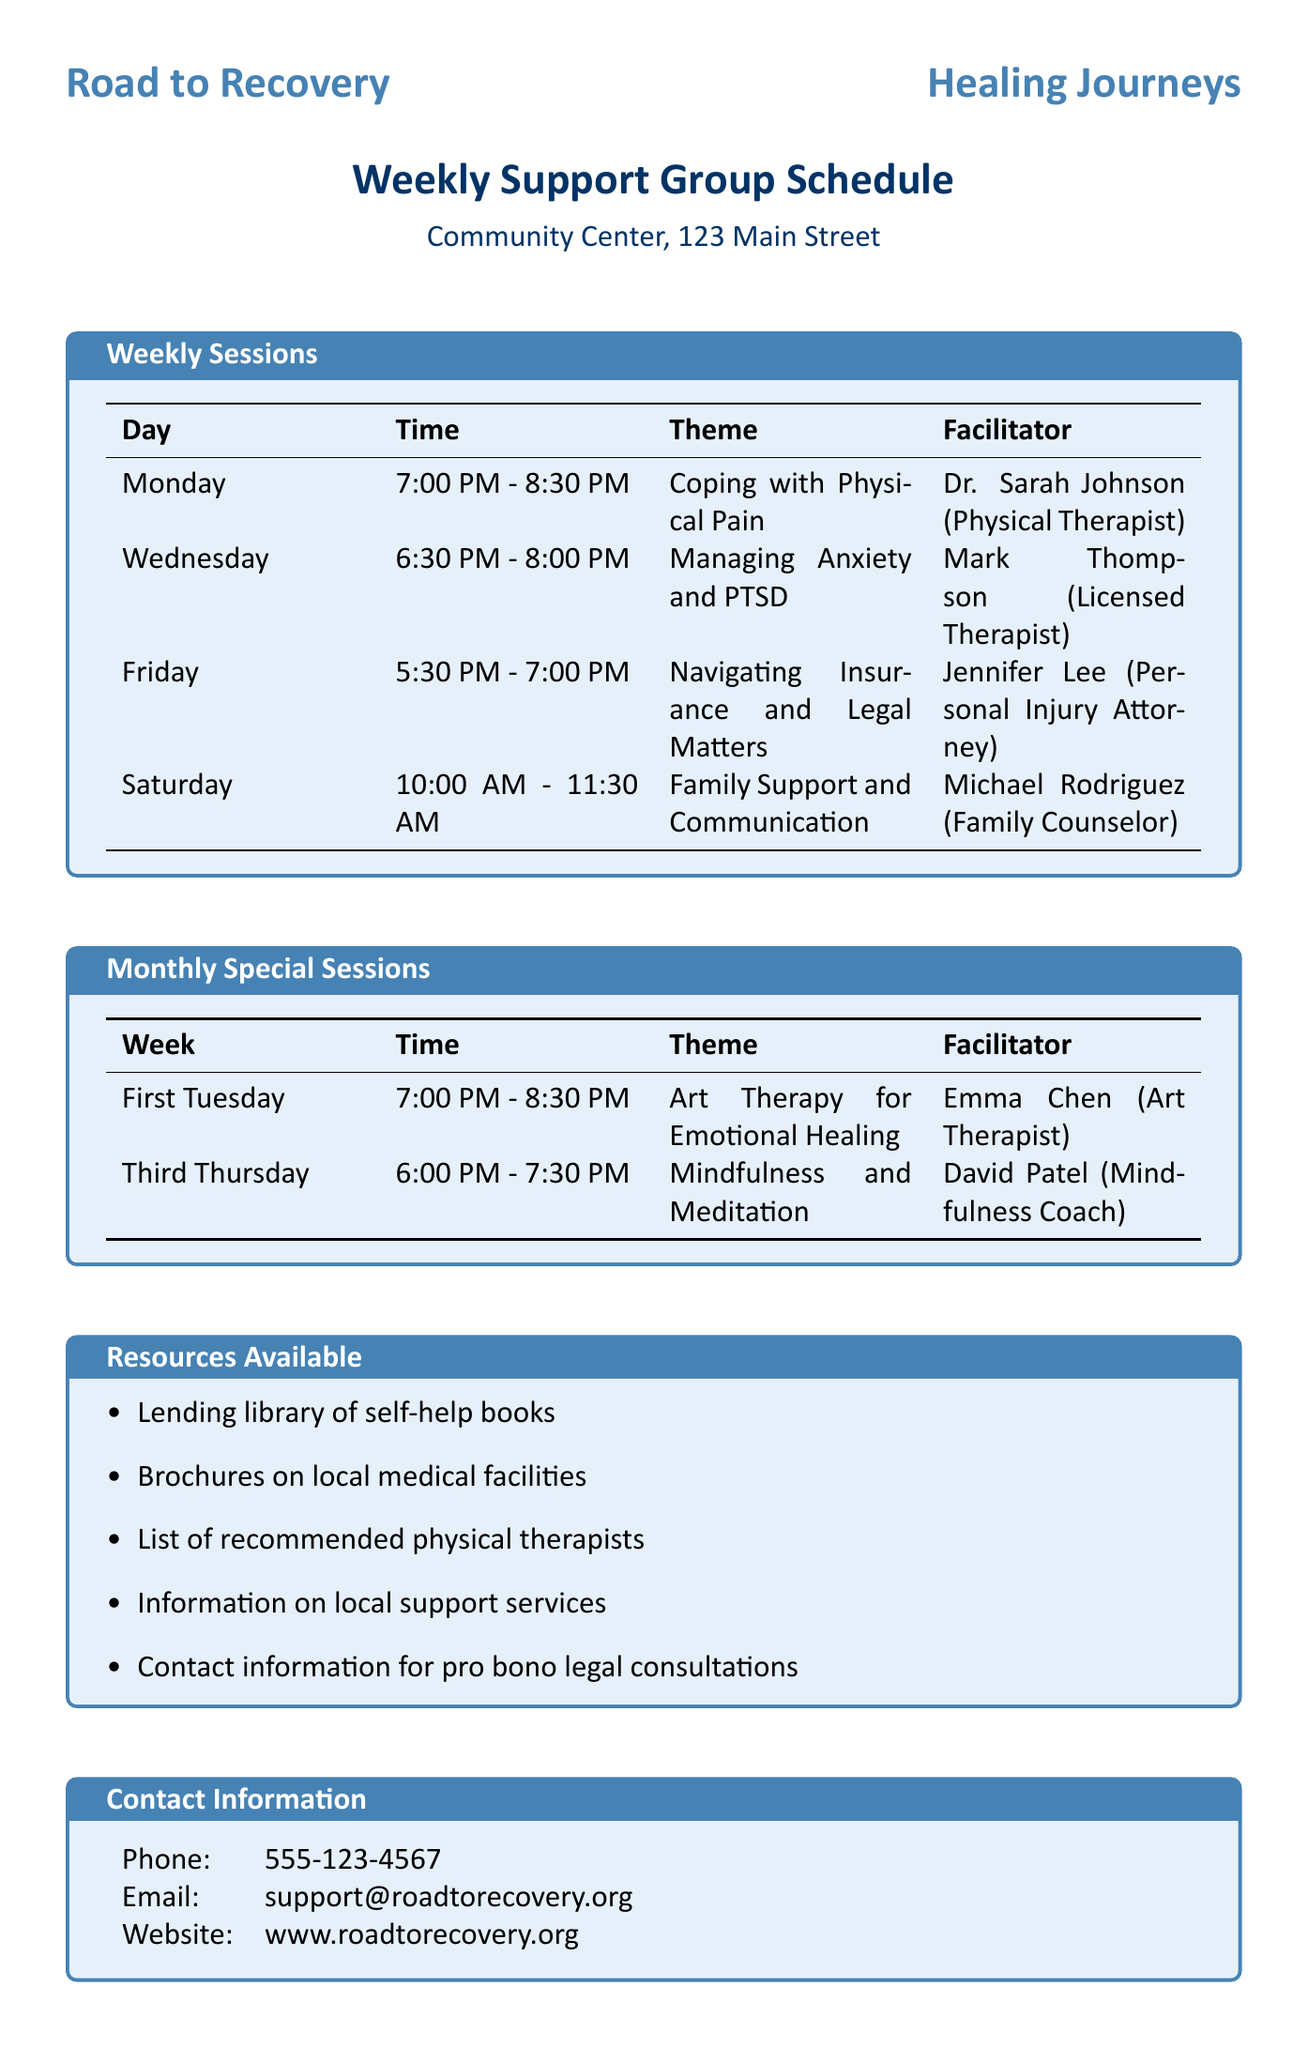What is the name of the organization? The name of the organization is listed at the top of the document, which is "Road to Recovery."
Answer: Road to Recovery What is the theme of the Wednesday session? The theme for the Wednesday session can be found in the schedule, which states "Managing Anxiety and PTSD."
Answer: Managing Anxiety and PTSD Who is the facilitator for the "Art Therapy for Emotional Healing" session? The facilitator for this monthly special session is provided in the document, which states "Emma Chen."
Answer: Emma Chen On which day is the session titled "Coping with Physical Pain" held? Referring to the weekly schedule, this theme is scheduled for "Monday."
Answer: Monday What time does the Friday session start? The start time for the Friday session is provided in the weekly schedule as "5:30 PM."
Answer: 5:30 PM Which session is facilitated by a Personal Injury Attorney? The document lists the thematic sessions, and it states "Navigating Insurance and Legal Matters" is facilitated by a Personal Injury Attorney, Jennifer Lee.
Answer: Navigating Insurance and Legal Matters How often do special sessions occur? The document specifies that these monthly sessions recur regularly based on specific weeks in a month.
Answer: Monthly Is childcare available during the sessions? The additional notes section mentions various supports, including whether childcare is provided, stating clearly that it is available upon request.
Answer: Yes How long is the "Family Support and Communication" session? The document lists the duration of this session in the schedule, which is "1 hour and 30 minutes."
Answer: 1 hour and 30 minutes 